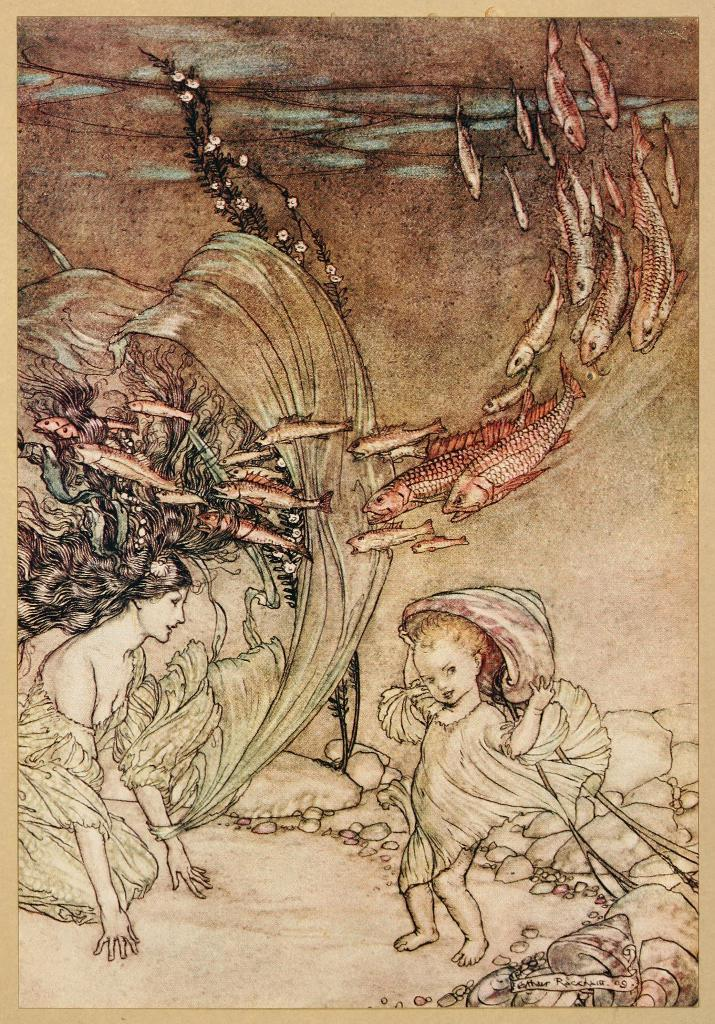What is depicted on the paper in the image? There are drawings of two people, fishes, and rocks on the paper. Can you describe the subjects of the drawings on the paper? The drawings on the paper depict two people, fishes, and rocks. What type of business is being conducted in the image? There is no indication of a business or any business-related activity in the image. What is being served for breakfast in the image? There is no reference to breakfast or any food in the image. 